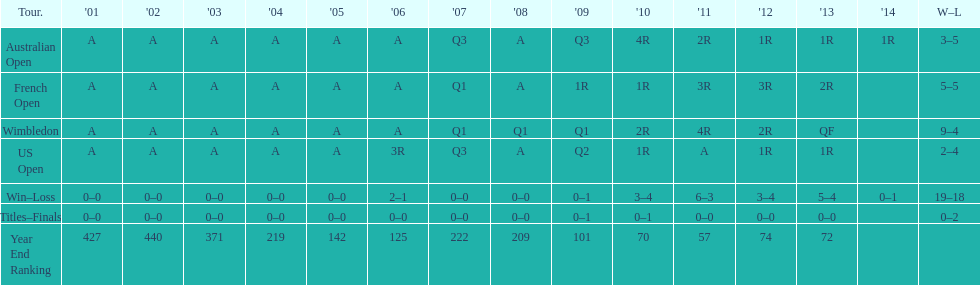What was this players ranking after 2005? 125. 